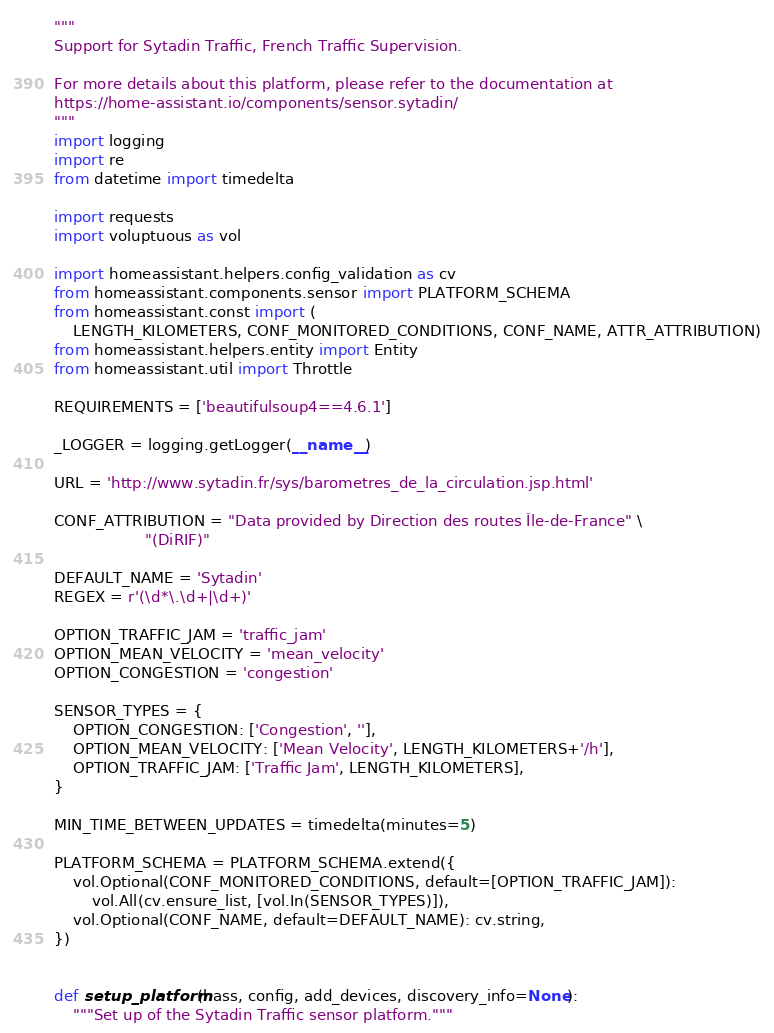Convert code to text. <code><loc_0><loc_0><loc_500><loc_500><_Python_>"""
Support for Sytadin Traffic, French Traffic Supervision.

For more details about this platform, please refer to the documentation at
https://home-assistant.io/components/sensor.sytadin/
"""
import logging
import re
from datetime import timedelta

import requests
import voluptuous as vol

import homeassistant.helpers.config_validation as cv
from homeassistant.components.sensor import PLATFORM_SCHEMA
from homeassistant.const import (
    LENGTH_KILOMETERS, CONF_MONITORED_CONDITIONS, CONF_NAME, ATTR_ATTRIBUTION)
from homeassistant.helpers.entity import Entity
from homeassistant.util import Throttle

REQUIREMENTS = ['beautifulsoup4==4.6.1']

_LOGGER = logging.getLogger(__name__)

URL = 'http://www.sytadin.fr/sys/barometres_de_la_circulation.jsp.html'

CONF_ATTRIBUTION = "Data provided by Direction des routes Île-de-France" \
                   "(DiRIF)"

DEFAULT_NAME = 'Sytadin'
REGEX = r'(\d*\.\d+|\d+)'

OPTION_TRAFFIC_JAM = 'traffic_jam'
OPTION_MEAN_VELOCITY = 'mean_velocity'
OPTION_CONGESTION = 'congestion'

SENSOR_TYPES = {
    OPTION_CONGESTION: ['Congestion', ''],
    OPTION_MEAN_VELOCITY: ['Mean Velocity', LENGTH_KILOMETERS+'/h'],
    OPTION_TRAFFIC_JAM: ['Traffic Jam', LENGTH_KILOMETERS],
}

MIN_TIME_BETWEEN_UPDATES = timedelta(minutes=5)

PLATFORM_SCHEMA = PLATFORM_SCHEMA.extend({
    vol.Optional(CONF_MONITORED_CONDITIONS, default=[OPTION_TRAFFIC_JAM]):
        vol.All(cv.ensure_list, [vol.In(SENSOR_TYPES)]),
    vol.Optional(CONF_NAME, default=DEFAULT_NAME): cv.string,
})


def setup_platform(hass, config, add_devices, discovery_info=None):
    """Set up of the Sytadin Traffic sensor platform."""</code> 